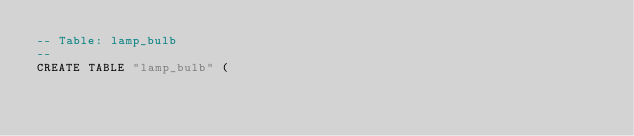Convert code to text. <code><loc_0><loc_0><loc_500><loc_500><_SQL_>-- Table: lamp_bulb
--
CREATE TABLE "lamp_bulb" (</code> 